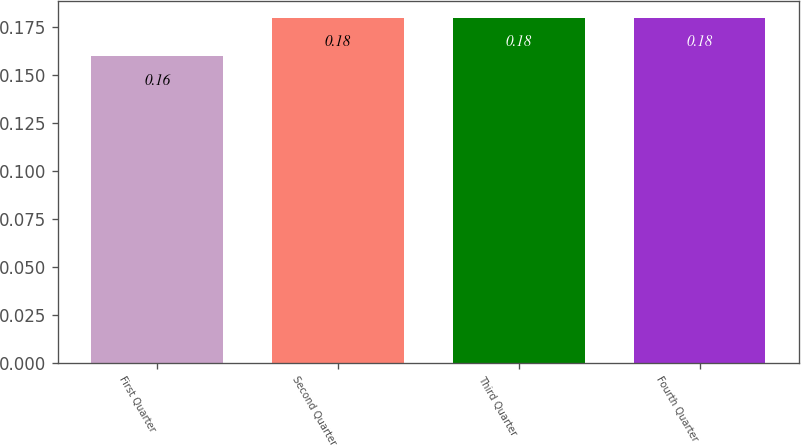Convert chart to OTSL. <chart><loc_0><loc_0><loc_500><loc_500><bar_chart><fcel>First Quarter<fcel>Second Quarter<fcel>Third Quarter<fcel>Fourth Quarter<nl><fcel>0.16<fcel>0.18<fcel>0.18<fcel>0.18<nl></chart> 